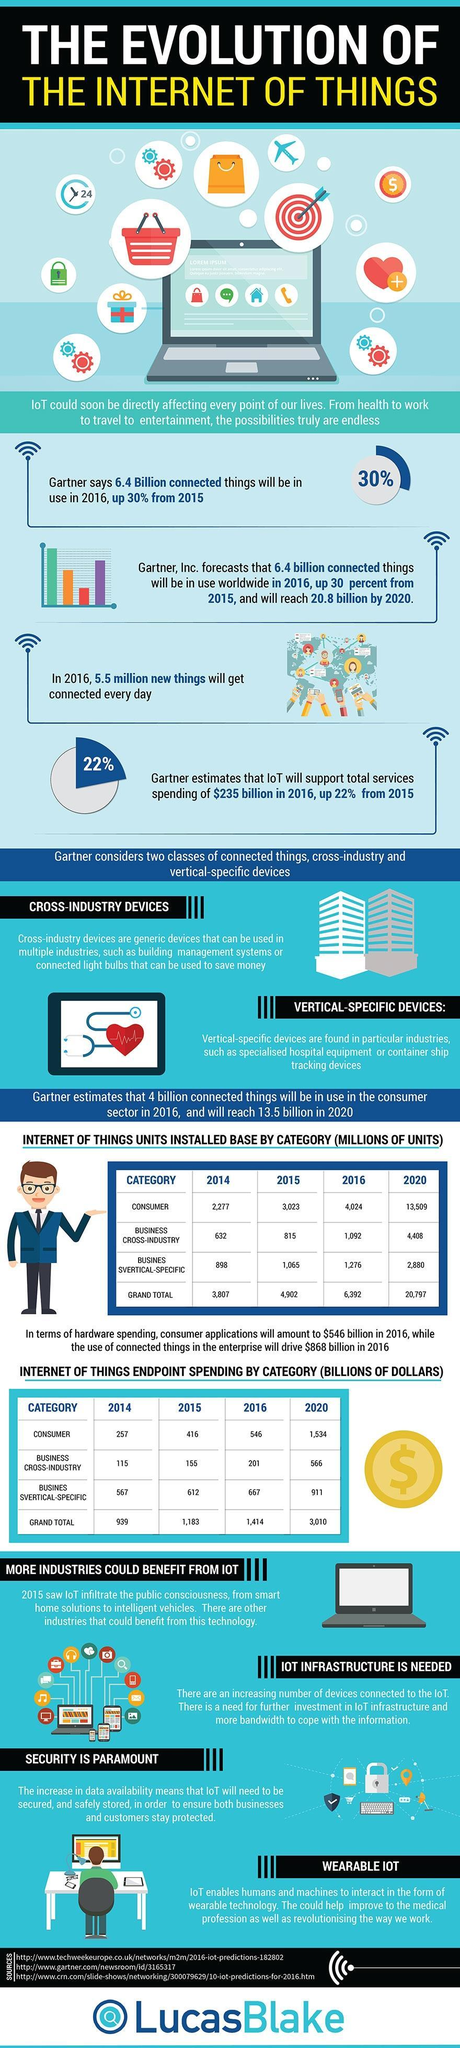What are the two types of devices mentioned in this infographic?
Answer the question with a short phrase. Cross-industry devices, Vertical-specific devices 